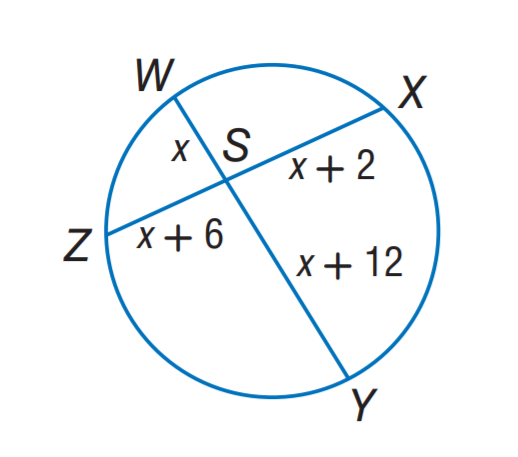Answer the mathemtical geometry problem and directly provide the correct option letter.
Question: Find x.
Choices: A: 2 B: 3 C: 4 D: 5 B 